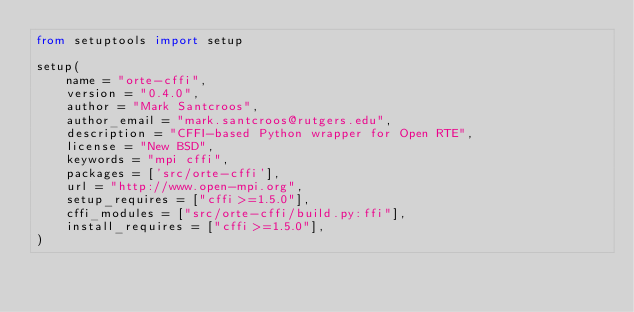<code> <loc_0><loc_0><loc_500><loc_500><_Python_>from setuptools import setup

setup(
    name = "orte-cffi",
    version = "0.4.0",
    author = "Mark Santcroos",
    author_email = "mark.santcroos@rutgers.edu",
    description = "CFFI-based Python wrapper for Open RTE",
    license = "New BSD",
    keywords = "mpi cffi",
    packages = ['src/orte-cffi'],
    url = "http://www.open-mpi.org",
    setup_requires = ["cffi>=1.5.0"],
    cffi_modules = ["src/orte-cffi/build.py:ffi"],
    install_requires = ["cffi>=1.5.0"],
)
</code> 